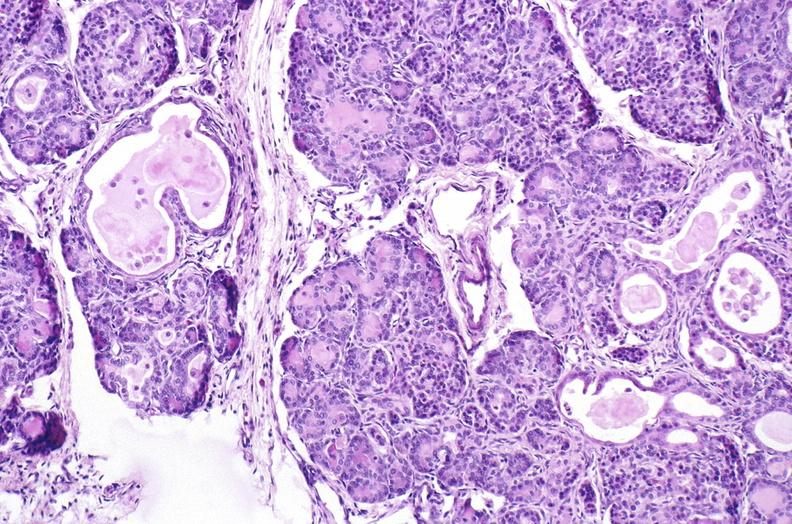what does this image show?
Answer the question using a single word or phrase. Cystic fibrosis 